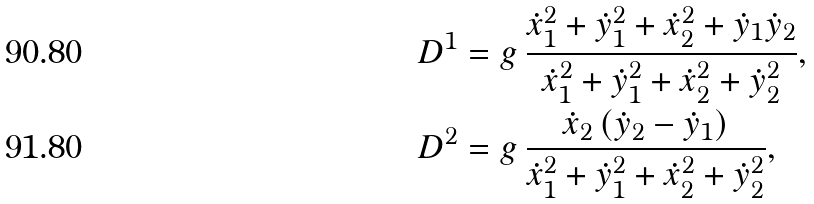<formula> <loc_0><loc_0><loc_500><loc_500>& D ^ { 1 } = g \, \frac { \dot { x } _ { 1 } ^ { 2 } + \dot { y } _ { 1 } ^ { 2 } + \dot { x } _ { 2 } ^ { 2 } + \dot { y } _ { 1 } \dot { y } _ { 2 } } { \dot { x } _ { 1 } ^ { 2 } + \dot { y } _ { 1 } ^ { 2 } + \dot { x } _ { 2 } ^ { 2 } + \dot { y } _ { 2 } ^ { 2 } } , \\ & D ^ { 2 } = g \, \frac { \dot { x } _ { 2 } \, ( \dot { y } _ { 2 } - \dot { y } _ { 1 } ) } { \dot { x } _ { 1 } ^ { 2 } + \dot { y } _ { 1 } ^ { 2 } + \dot { x } _ { 2 } ^ { 2 } + \dot { y } _ { 2 } ^ { 2 } } ,</formula> 